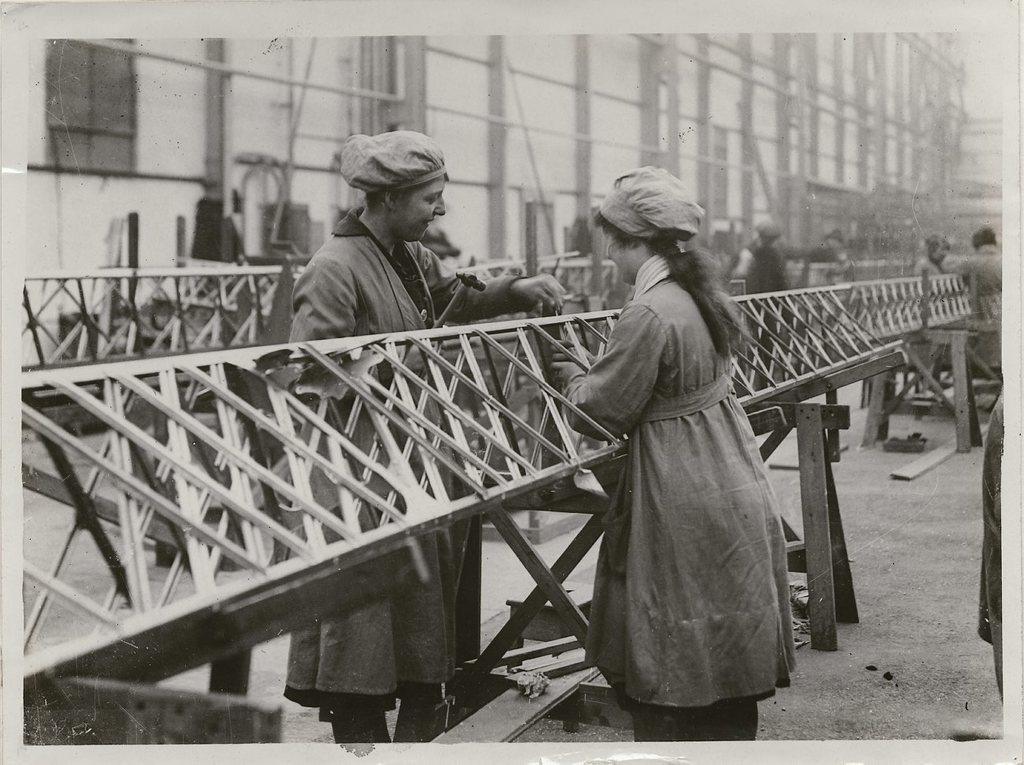What are the people in the image doing? The people in the image are standing near rods. What can be seen in the background of the image? There is a building in the background of the image. What is the color scheme of the image? The image is black and white. Can you tell me how many leaves are on the ground in the image? There are no leaves present in the image; it is a black and white image featuring people standing near rods with a building in the background. 